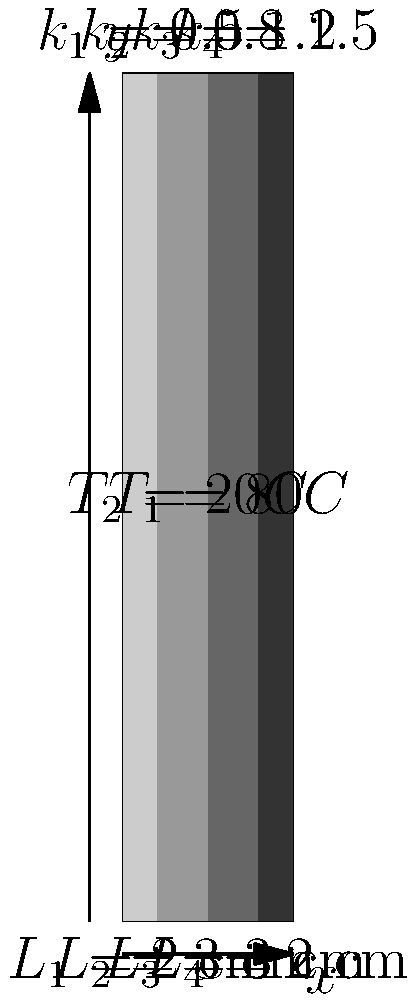A composite wall consists of four layers with different materials and thicknesses, as shown in the diagram. The temperature on the left side of the wall is $80°C$, and on the right side is $20°C$. The thermal conductivities ($k$) and thicknesses ($L$) of each layer are given in the diagram. Calculate the heat transfer rate per unit area through this composite wall. To solve this problem, we'll use the concept of thermal resistance in series for a composite wall. Here's the step-by-step solution:

1. Calculate the thermal resistance of each layer:
   $R_i = \frac{L_i}{k_i}$
   
   $R_1 = \frac{0.02}{0.5} = 0.04$ m²K/W
   $R_2 = \frac{0.03}{0.8} = 0.0375$ m²K/W
   $R_3 = \frac{0.03}{1.2} = 0.025$ m²K/W
   $R_4 = \frac{0.02}{1.5} = 0.0133$ m²K/W

2. Calculate the total thermal resistance:
   $R_{total} = R_1 + R_2 + R_3 + R_4$
   $R_{total} = 0.04 + 0.0375 + 0.025 + 0.0133 = 0.1158$ m²K/W

3. Calculate the temperature difference:
   $\Delta T = T_1 - T_2 = 80°C - 20°C = 60°C$

4. Use Fourier's Law of heat conduction to calculate the heat transfer rate per unit area:
   $q = \frac{\Delta T}{R_{total}}$
   $q = \frac{60}{0.1158} = 518.13$ W/m²

Therefore, the heat transfer rate per unit area through the composite wall is approximately 518.13 W/m².
Answer: 518.13 W/m² 